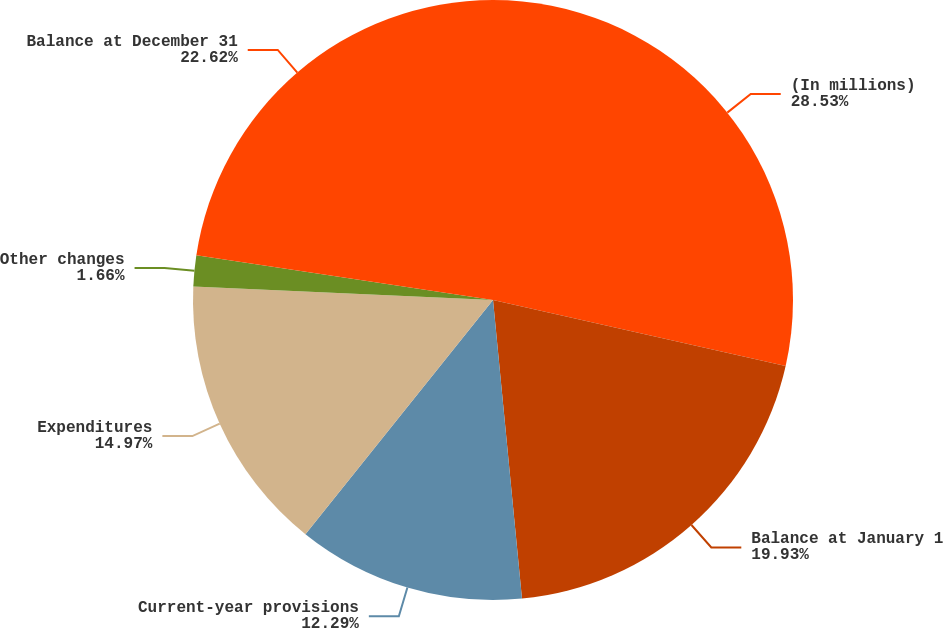Convert chart. <chart><loc_0><loc_0><loc_500><loc_500><pie_chart><fcel>(In millions)<fcel>Balance at January 1<fcel>Current-year provisions<fcel>Expenditures<fcel>Other changes<fcel>Balance at December 31<nl><fcel>28.53%<fcel>19.93%<fcel>12.29%<fcel>14.97%<fcel>1.66%<fcel>22.62%<nl></chart> 